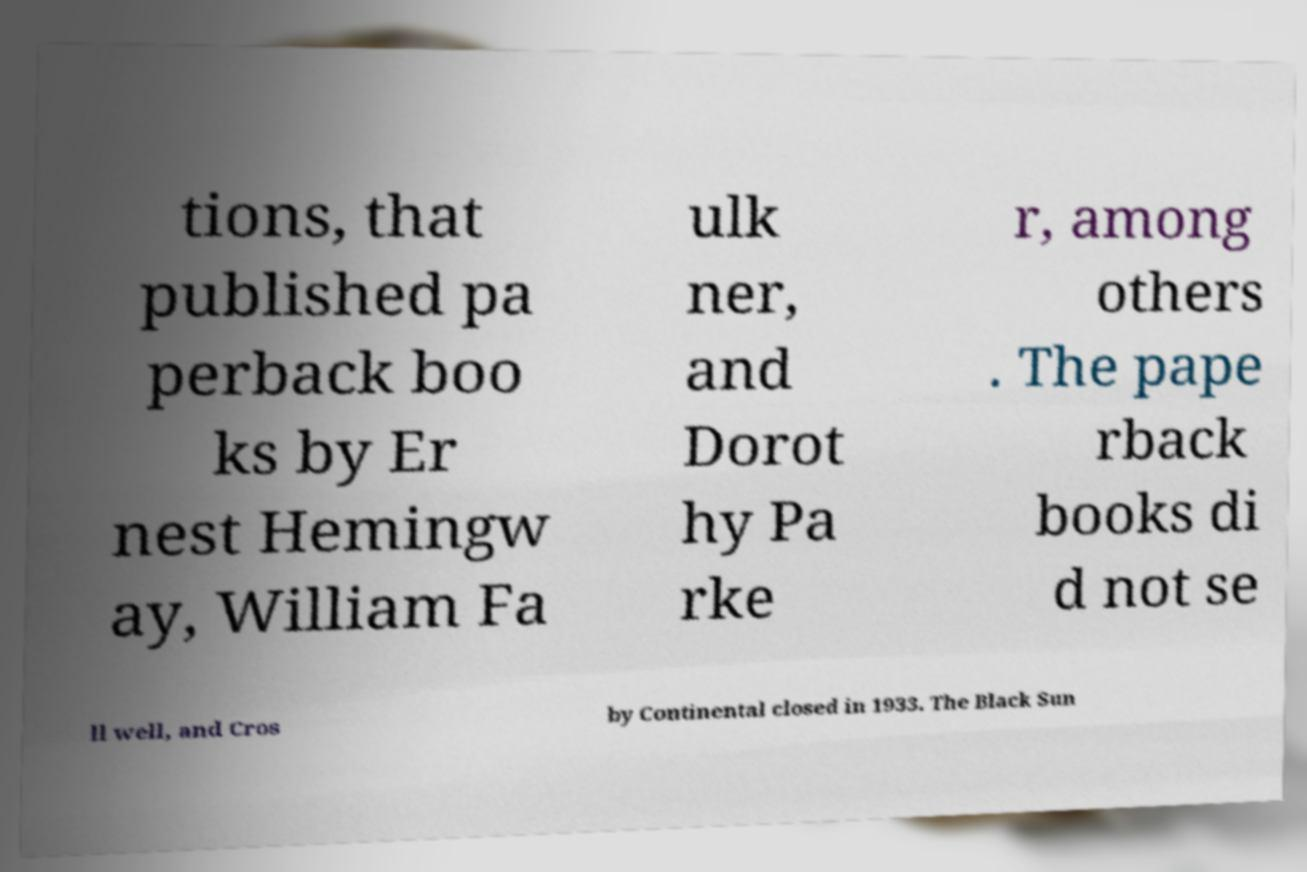Could you extract and type out the text from this image? tions, that published pa perback boo ks by Er nest Hemingw ay, William Fa ulk ner, and Dorot hy Pa rke r, among others . The pape rback books di d not se ll well, and Cros by Continental closed in 1933. The Black Sun 